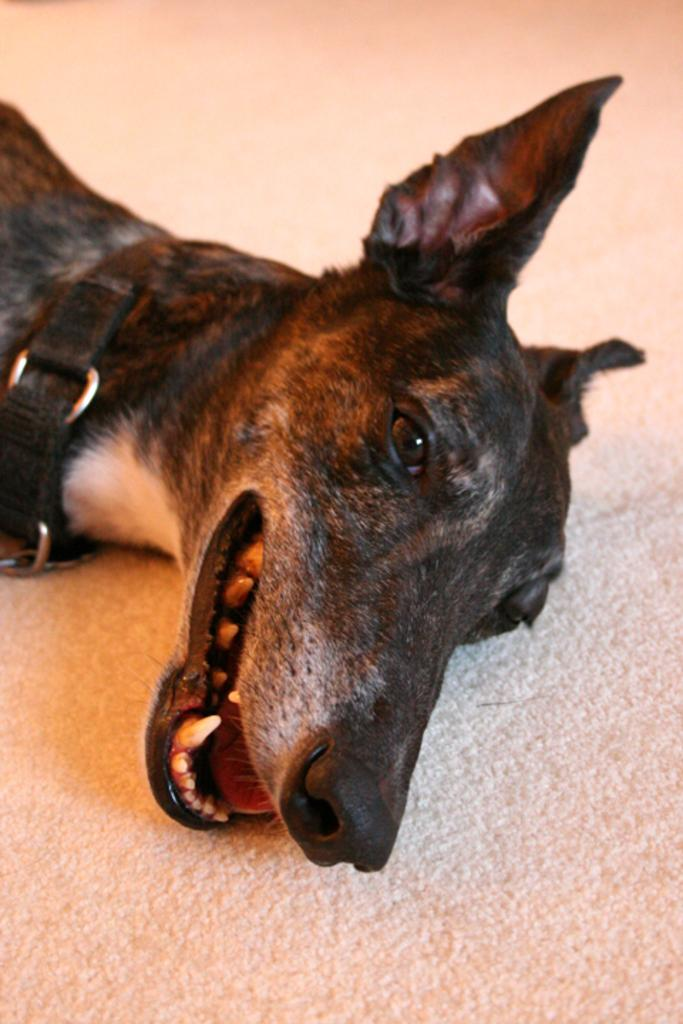What type of animal is in the image? There is a black dog in the image. What is the color of the surface the dog is on? The dog is on a white surface. What is the texture of the moon in the image? There is no moon present in the image; it features a black dog on a white surface. How does the dog's stomach appear in the image? The image does not show the dog's stomach; it only shows the dog's body from the side. 